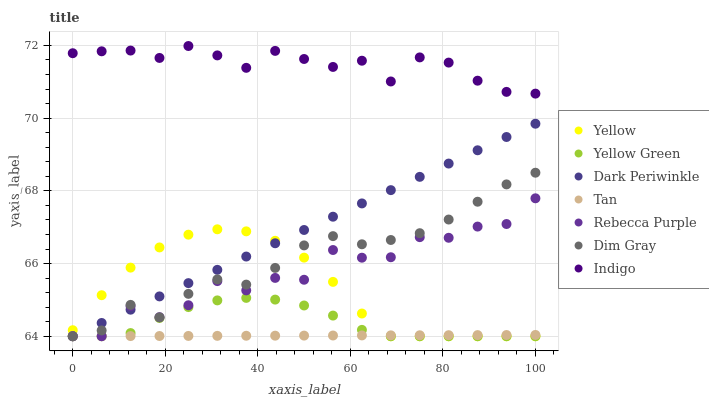Does Tan have the minimum area under the curve?
Answer yes or no. Yes. Does Indigo have the maximum area under the curve?
Answer yes or no. Yes. Does Yellow Green have the minimum area under the curve?
Answer yes or no. No. Does Yellow Green have the maximum area under the curve?
Answer yes or no. No. Is Dark Periwinkle the smoothest?
Answer yes or no. Yes. Is Rebecca Purple the roughest?
Answer yes or no. Yes. Is Indigo the smoothest?
Answer yes or no. No. Is Indigo the roughest?
Answer yes or no. No. Does Dim Gray have the lowest value?
Answer yes or no. Yes. Does Indigo have the lowest value?
Answer yes or no. No. Does Indigo have the highest value?
Answer yes or no. Yes. Does Yellow Green have the highest value?
Answer yes or no. No. Is Yellow less than Indigo?
Answer yes or no. Yes. Is Indigo greater than Tan?
Answer yes or no. Yes. Does Yellow Green intersect Tan?
Answer yes or no. Yes. Is Yellow Green less than Tan?
Answer yes or no. No. Is Yellow Green greater than Tan?
Answer yes or no. No. Does Yellow intersect Indigo?
Answer yes or no. No. 